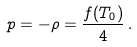Convert formula to latex. <formula><loc_0><loc_0><loc_500><loc_500>p = - \rho = \frac { f ( T _ { 0 } ) } { 4 } \, .</formula> 